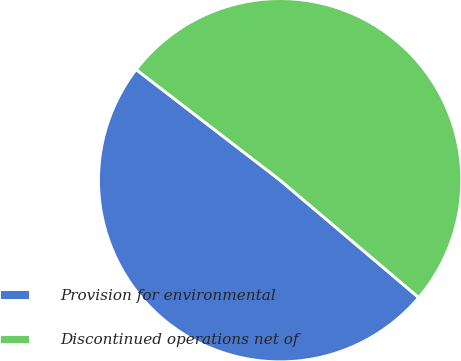<chart> <loc_0><loc_0><loc_500><loc_500><pie_chart><fcel>Provision for environmental<fcel>Discontinued operations net of<nl><fcel>49.25%<fcel>50.75%<nl></chart> 